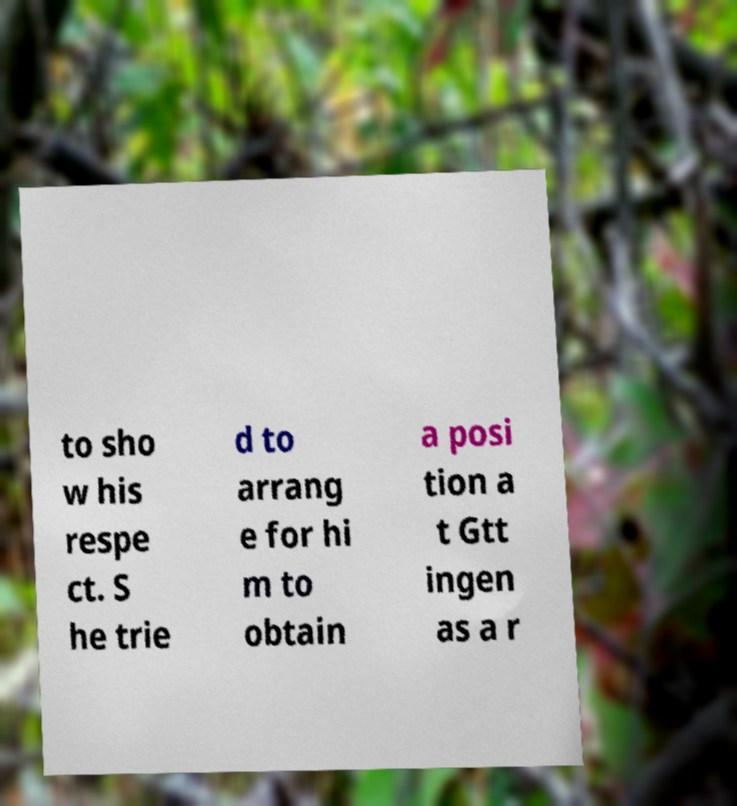Could you extract and type out the text from this image? to sho w his respe ct. S he trie d to arrang e for hi m to obtain a posi tion a t Gtt ingen as a r 